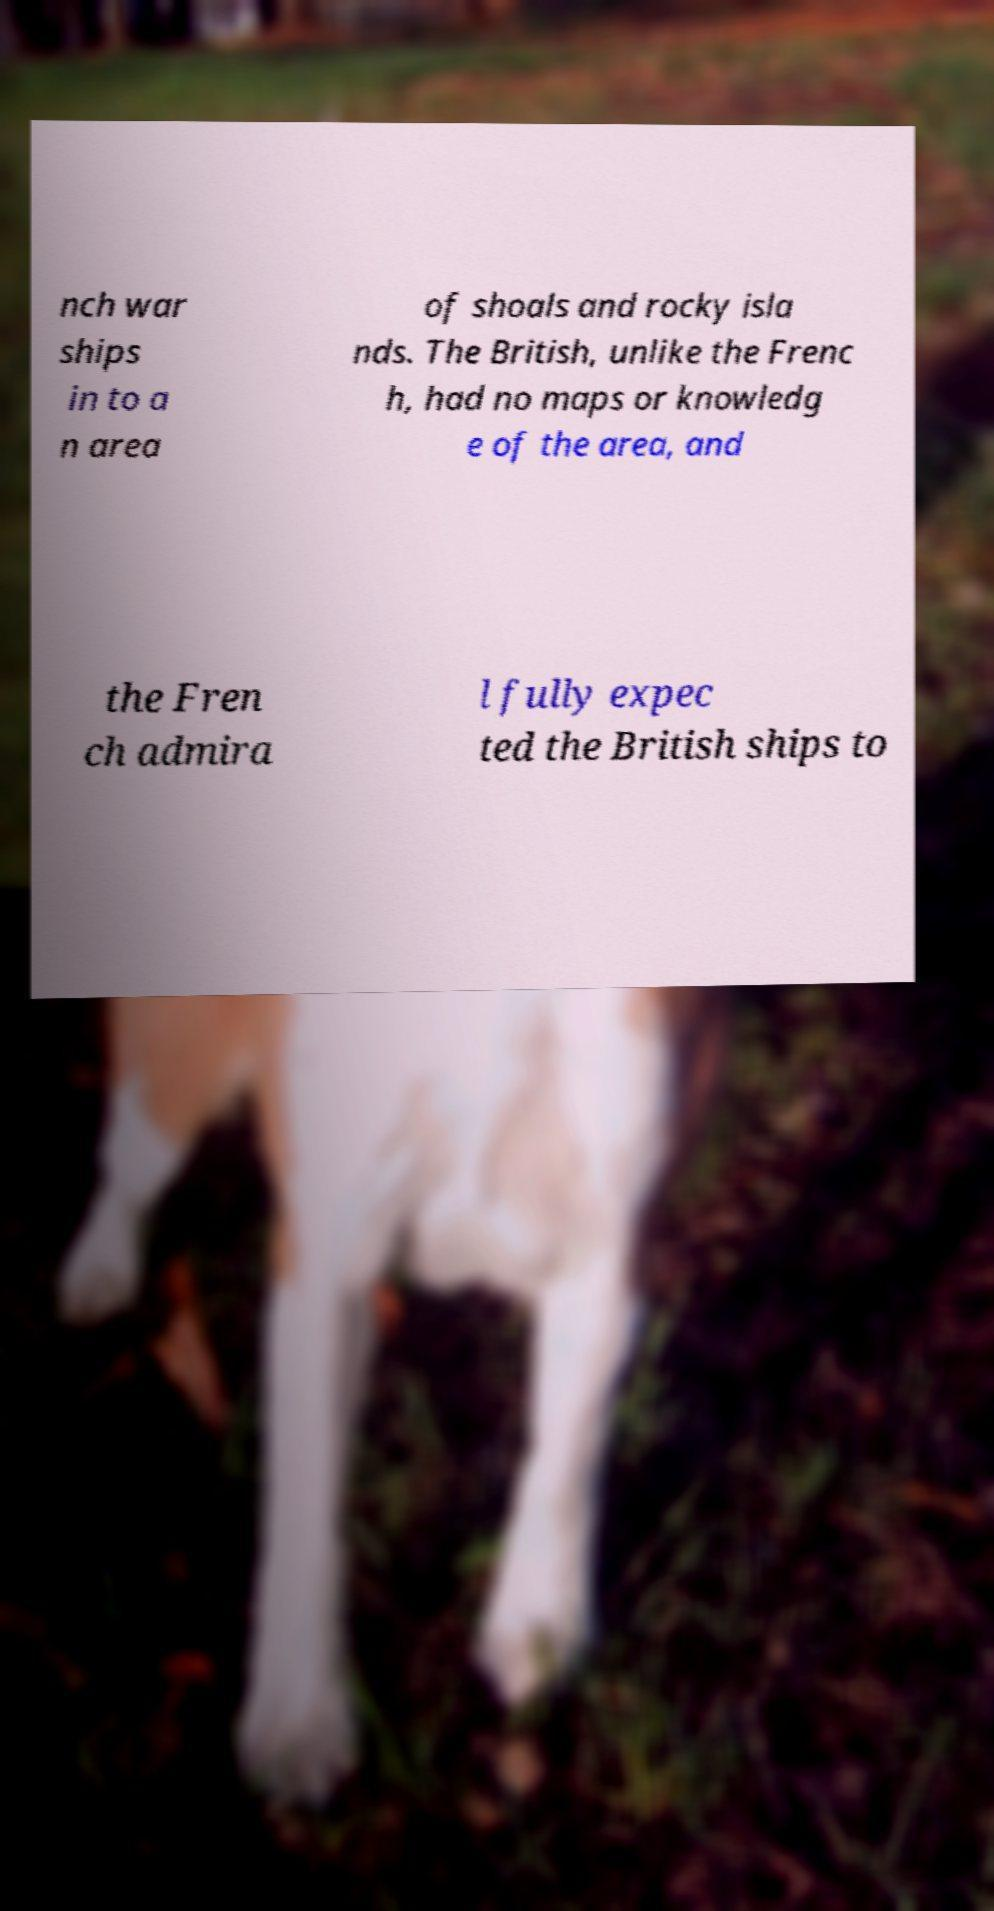Please read and relay the text visible in this image. What does it say? nch war ships in to a n area of shoals and rocky isla nds. The British, unlike the Frenc h, had no maps or knowledg e of the area, and the Fren ch admira l fully expec ted the British ships to 